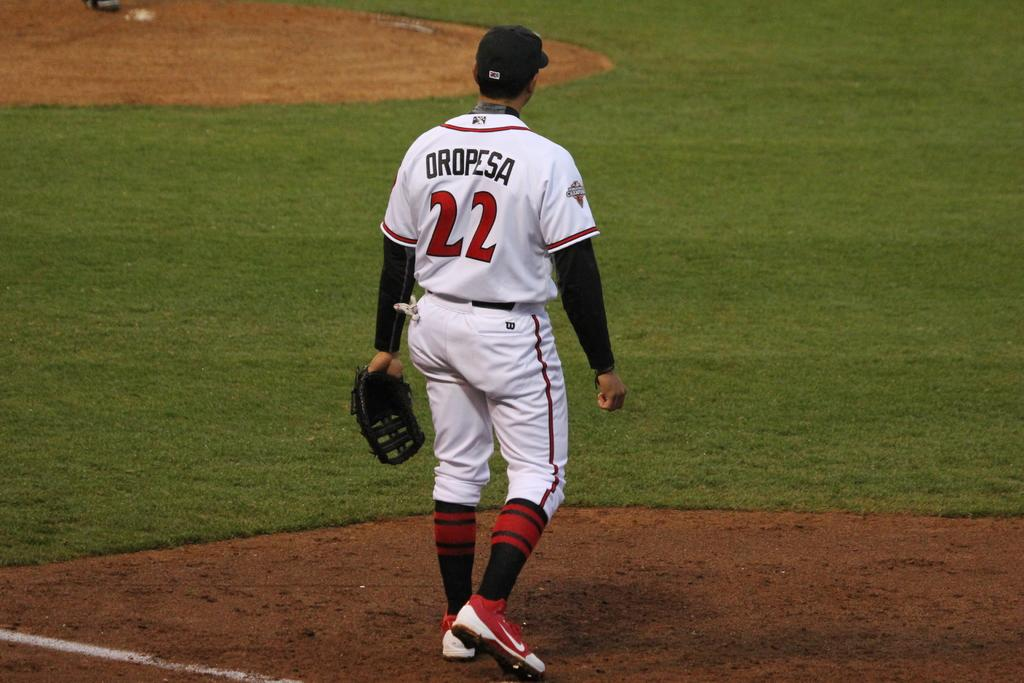Provide a one-sentence caption for the provided image. A man in a baseball uniform with the number 22. 